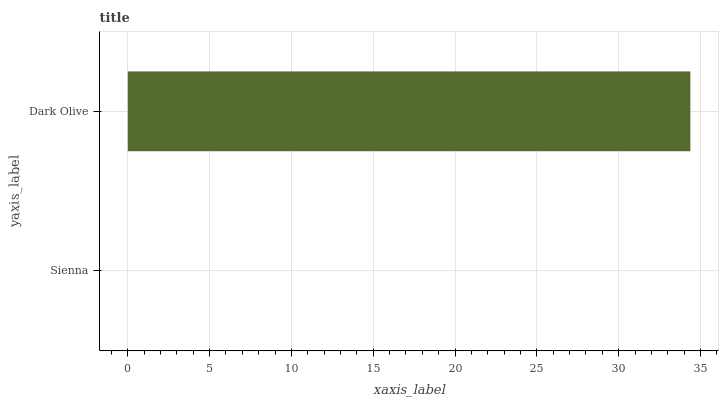Is Sienna the minimum?
Answer yes or no. Yes. Is Dark Olive the maximum?
Answer yes or no. Yes. Is Dark Olive the minimum?
Answer yes or no. No. Is Dark Olive greater than Sienna?
Answer yes or no. Yes. Is Sienna less than Dark Olive?
Answer yes or no. Yes. Is Sienna greater than Dark Olive?
Answer yes or no. No. Is Dark Olive less than Sienna?
Answer yes or no. No. Is Dark Olive the high median?
Answer yes or no. Yes. Is Sienna the low median?
Answer yes or no. Yes. Is Sienna the high median?
Answer yes or no. No. Is Dark Olive the low median?
Answer yes or no. No. 